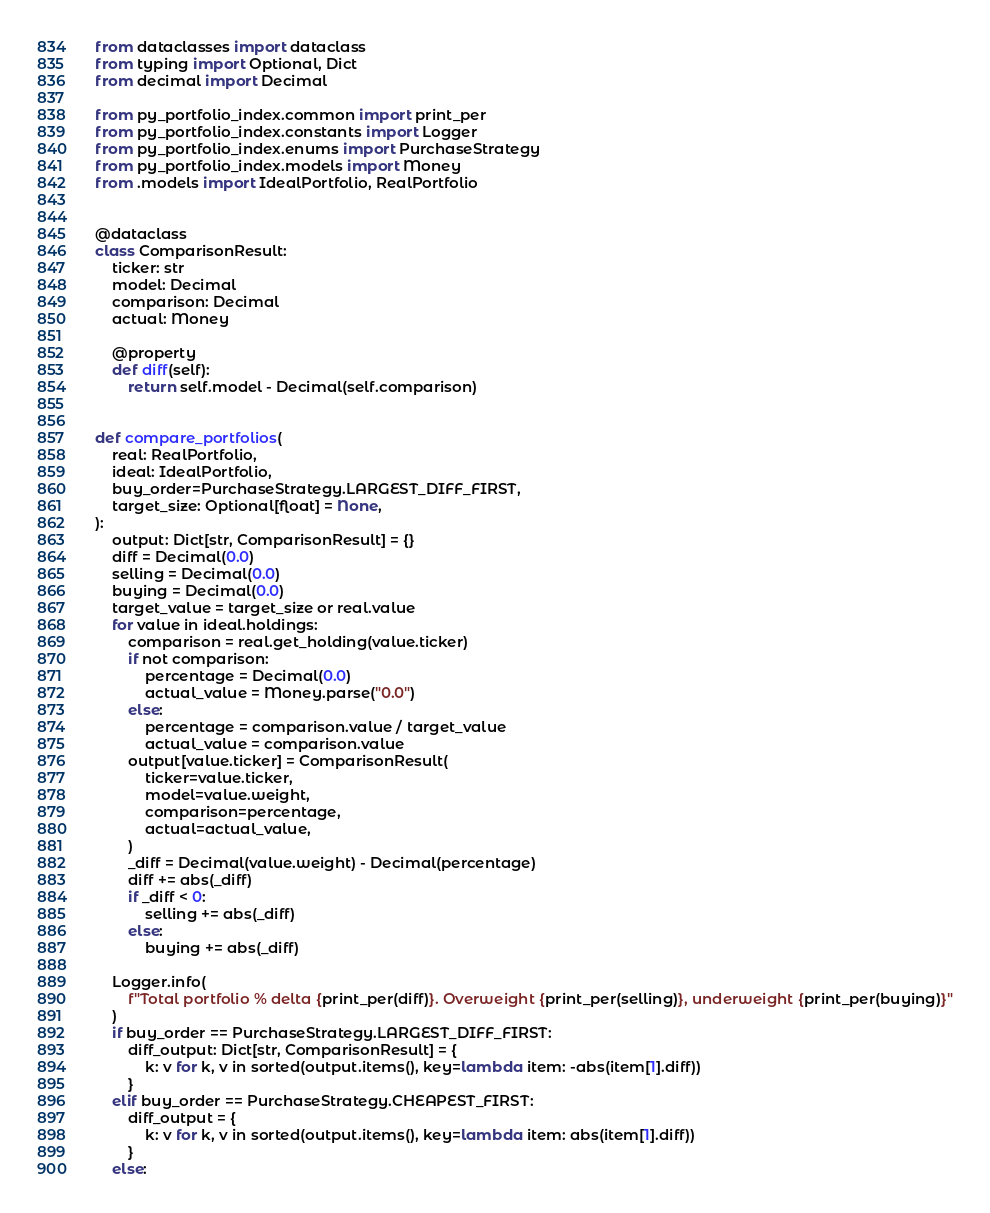<code> <loc_0><loc_0><loc_500><loc_500><_Python_>from dataclasses import dataclass
from typing import Optional, Dict
from decimal import Decimal

from py_portfolio_index.common import print_per
from py_portfolio_index.constants import Logger
from py_portfolio_index.enums import PurchaseStrategy
from py_portfolio_index.models import Money
from .models import IdealPortfolio, RealPortfolio


@dataclass
class ComparisonResult:
    ticker: str
    model: Decimal
    comparison: Decimal
    actual: Money

    @property
    def diff(self):
        return self.model - Decimal(self.comparison)


def compare_portfolios(
    real: RealPortfolio,
    ideal: IdealPortfolio,
    buy_order=PurchaseStrategy.LARGEST_DIFF_FIRST,
    target_size: Optional[float] = None,
):
    output: Dict[str, ComparisonResult] = {}
    diff = Decimal(0.0)
    selling = Decimal(0.0)
    buying = Decimal(0.0)
    target_value = target_size or real.value
    for value in ideal.holdings:
        comparison = real.get_holding(value.ticker)
        if not comparison:
            percentage = Decimal(0.0)
            actual_value = Money.parse("0.0")
        else:
            percentage = comparison.value / target_value
            actual_value = comparison.value
        output[value.ticker] = ComparisonResult(
            ticker=value.ticker,
            model=value.weight,
            comparison=percentage,
            actual=actual_value,
        )
        _diff = Decimal(value.weight) - Decimal(percentage)
        diff += abs(_diff)
        if _diff < 0:
            selling += abs(_diff)
        else:
            buying += abs(_diff)

    Logger.info(
        f"Total portfolio % delta {print_per(diff)}. Overweight {print_per(selling)}, underweight {print_per(buying)}"
    )
    if buy_order == PurchaseStrategy.LARGEST_DIFF_FIRST:
        diff_output: Dict[str, ComparisonResult] = {
            k: v for k, v in sorted(output.items(), key=lambda item: -abs(item[1].diff))
        }
    elif buy_order == PurchaseStrategy.CHEAPEST_FIRST:
        diff_output = {
            k: v for k, v in sorted(output.items(), key=lambda item: abs(item[1].diff))
        }
    else:</code> 